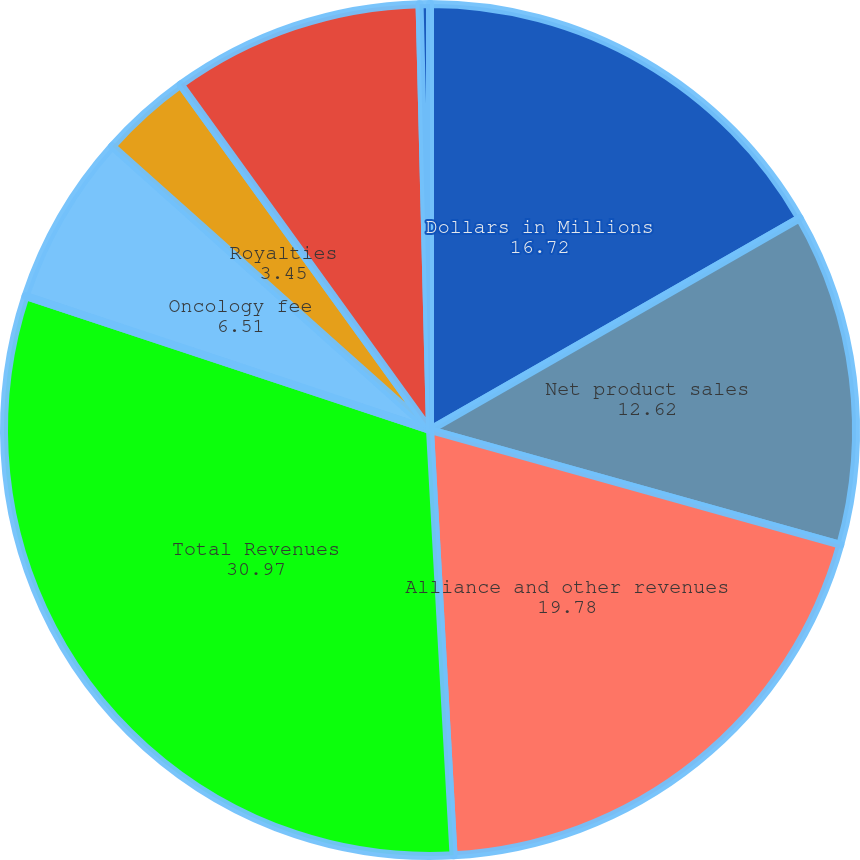Convert chart to OTSL. <chart><loc_0><loc_0><loc_500><loc_500><pie_chart><fcel>Dollars in Millions<fcel>Net product sales<fcel>Alliance and other revenues<fcel>Total Revenues<fcel>Oncology fee<fcel>Royalties<fcel>Cost of product supply<fcel>Cost reimbursements to/(from)<nl><fcel>16.72%<fcel>12.62%<fcel>19.78%<fcel>30.97%<fcel>6.51%<fcel>3.45%<fcel>9.56%<fcel>0.39%<nl></chart> 